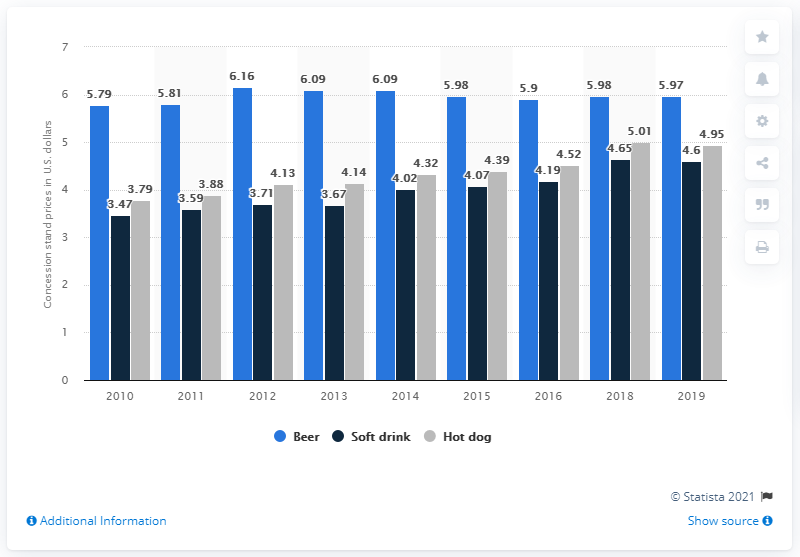Specify some key components in this picture. In 2019, the average price of a hot dog was 4.95. The difference between the highest light blue bar and the lowest dark blue bar is 2.69... The average price of beer from 2010 to 2019 was 5.97. 